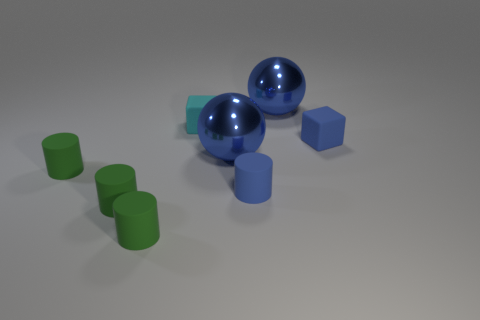Subtract all red spheres. How many green cylinders are left? 3 Subtract all small blue cylinders. How many cylinders are left? 3 Add 1 small blue things. How many objects exist? 9 Subtract all blue cylinders. How many cylinders are left? 3 Subtract 1 cylinders. How many cylinders are left? 3 Add 3 cyan rubber objects. How many cyan rubber objects are left? 4 Add 1 small blue things. How many small blue things exist? 3 Subtract 0 cyan spheres. How many objects are left? 8 Subtract all balls. How many objects are left? 6 Subtract all gray cylinders. Subtract all red cubes. How many cylinders are left? 4 